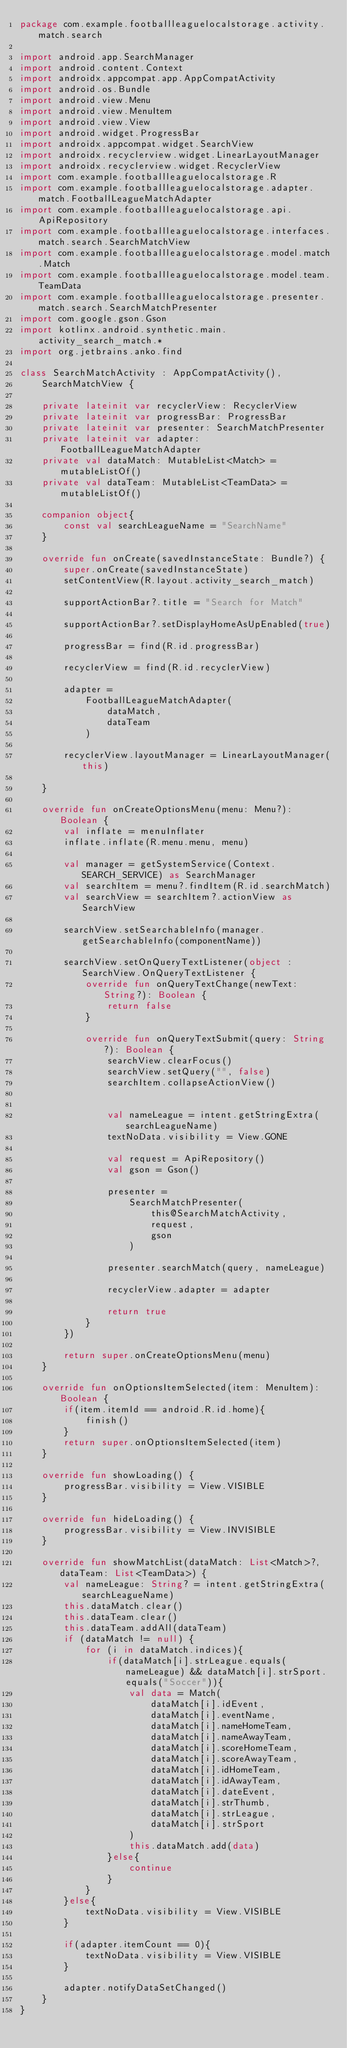Convert code to text. <code><loc_0><loc_0><loc_500><loc_500><_Kotlin_>package com.example.footballleaguelocalstorage.activity.match.search

import android.app.SearchManager
import android.content.Context
import androidx.appcompat.app.AppCompatActivity
import android.os.Bundle
import android.view.Menu
import android.view.MenuItem
import android.view.View
import android.widget.ProgressBar
import androidx.appcompat.widget.SearchView
import androidx.recyclerview.widget.LinearLayoutManager
import androidx.recyclerview.widget.RecyclerView
import com.example.footballleaguelocalstorage.R
import com.example.footballleaguelocalstorage.adapter.match.FootballLeagueMatchAdapter
import com.example.footballleaguelocalstorage.api.ApiRepository
import com.example.footballleaguelocalstorage.interfaces.match.search.SearchMatchView
import com.example.footballleaguelocalstorage.model.match.Match
import com.example.footballleaguelocalstorage.model.team.TeamData
import com.example.footballleaguelocalstorage.presenter.match.search.SearchMatchPresenter
import com.google.gson.Gson
import kotlinx.android.synthetic.main.activity_search_match.*
import org.jetbrains.anko.find

class SearchMatchActivity : AppCompatActivity(),
    SearchMatchView {

    private lateinit var recyclerView: RecyclerView
    private lateinit var progressBar: ProgressBar
    private lateinit var presenter: SearchMatchPresenter
    private lateinit var adapter: FootballLeagueMatchAdapter
    private val dataMatch: MutableList<Match> = mutableListOf()
    private val dataTeam: MutableList<TeamData> = mutableListOf()

    companion object{
        const val searchLeagueName = "SearchName"
    }

    override fun onCreate(savedInstanceState: Bundle?) {
        super.onCreate(savedInstanceState)
        setContentView(R.layout.activity_search_match)

        supportActionBar?.title = "Search for Match"

        supportActionBar?.setDisplayHomeAsUpEnabled(true)

        progressBar = find(R.id.progressBar)

        recyclerView = find(R.id.recyclerView)

        adapter =
            FootballLeagueMatchAdapter(
                dataMatch,
                dataTeam
            )

        recyclerView.layoutManager = LinearLayoutManager(this)

    }

    override fun onCreateOptionsMenu(menu: Menu?): Boolean {
        val inflate = menuInflater
        inflate.inflate(R.menu.menu, menu)

        val manager = getSystemService(Context.SEARCH_SERVICE) as SearchManager
        val searchItem = menu?.findItem(R.id.searchMatch)
        val searchView = searchItem?.actionView as SearchView

        searchView.setSearchableInfo(manager.getSearchableInfo(componentName))

        searchView.setOnQueryTextListener(object : SearchView.OnQueryTextListener {
            override fun onQueryTextChange(newText: String?): Boolean {
                return false
            }

            override fun onQueryTextSubmit(query: String?): Boolean {
                searchView.clearFocus()
                searchView.setQuery("", false)
                searchItem.collapseActionView()


                val nameLeague = intent.getStringExtra(searchLeagueName)
                textNoData.visibility = View.GONE

                val request = ApiRepository()
                val gson = Gson()

                presenter =
                    SearchMatchPresenter(
                        this@SearchMatchActivity,
                        request,
                        gson
                    )

                presenter.searchMatch(query, nameLeague)

                recyclerView.adapter = adapter

                return true
            }
        })

        return super.onCreateOptionsMenu(menu)
    }

    override fun onOptionsItemSelected(item: MenuItem): Boolean {
        if(item.itemId == android.R.id.home){
            finish()
        }
        return super.onOptionsItemSelected(item)
    }

    override fun showLoading() {
        progressBar.visibility = View.VISIBLE
    }

    override fun hideLoading() {
        progressBar.visibility = View.INVISIBLE
    }

    override fun showMatchList(dataMatch: List<Match>?, dataTeam: List<TeamData>) {
        val nameLeague: String? = intent.getStringExtra(searchLeagueName)
        this.dataMatch.clear()
        this.dataTeam.clear()
        this.dataTeam.addAll(dataTeam)
        if (dataMatch != null) {
            for (i in dataMatch.indices){
                if(dataMatch[i].strLeague.equals(nameLeague) && dataMatch[i].strSport.equals("Soccer")){
                    val data = Match(
                        dataMatch[i].idEvent,
                        dataMatch[i].eventName,
                        dataMatch[i].nameHomeTeam,
                        dataMatch[i].nameAwayTeam,
                        dataMatch[i].scoreHomeTeam,
                        dataMatch[i].scoreAwayTeam,
                        dataMatch[i].idHomeTeam,
                        dataMatch[i].idAwayTeam,
                        dataMatch[i].dateEvent,
                        dataMatch[i].strThumb,
                        dataMatch[i].strLeague,
                        dataMatch[i].strSport
                    )
                    this.dataMatch.add(data)
                }else{
                    continue
                }
            }
        }else{
            textNoData.visibility = View.VISIBLE
        }

        if(adapter.itemCount == 0){
            textNoData.visibility = View.VISIBLE
        }

        adapter.notifyDataSetChanged()
    }
}
</code> 